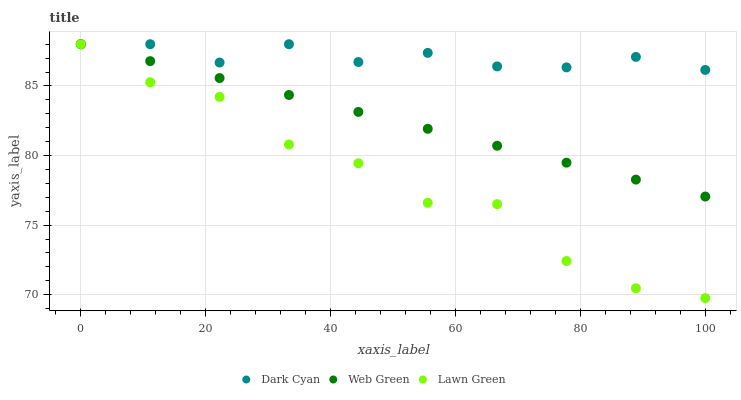Does Lawn Green have the minimum area under the curve?
Answer yes or no. Yes. Does Dark Cyan have the maximum area under the curve?
Answer yes or no. Yes. Does Web Green have the minimum area under the curve?
Answer yes or no. No. Does Web Green have the maximum area under the curve?
Answer yes or no. No. Is Web Green the smoothest?
Answer yes or no. Yes. Is Lawn Green the roughest?
Answer yes or no. Yes. Is Lawn Green the smoothest?
Answer yes or no. No. Is Web Green the roughest?
Answer yes or no. No. Does Lawn Green have the lowest value?
Answer yes or no. Yes. Does Web Green have the lowest value?
Answer yes or no. No. Does Web Green have the highest value?
Answer yes or no. Yes. Does Lawn Green intersect Dark Cyan?
Answer yes or no. Yes. Is Lawn Green less than Dark Cyan?
Answer yes or no. No. Is Lawn Green greater than Dark Cyan?
Answer yes or no. No. 